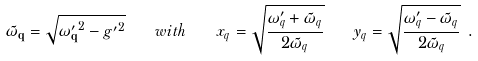<formula> <loc_0><loc_0><loc_500><loc_500>\tilde { \omega } _ { \mathbf q } = \sqrt { { \omega ^ { \prime } _ { \mathbf q } } ^ { 2 } - { g ^ { \prime } } ^ { 2 } } \quad w i t h \quad x _ { q } = \sqrt { \frac { \omega ^ { \prime } _ { q } + \tilde { \omega } _ { q } } { 2 \tilde { \omega } _ { q } } } \quad y _ { q } = \sqrt { \frac { \omega ^ { \prime } _ { q } - \tilde { \omega } _ { q } } { 2 \tilde { \omega } _ { q } } } \ .</formula> 